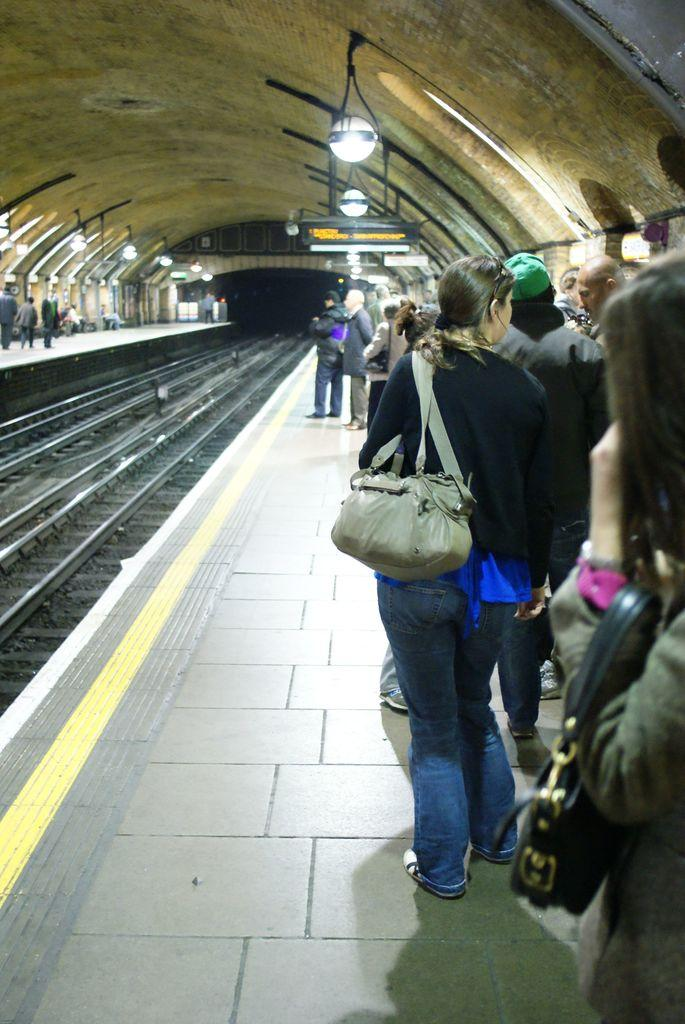What are the persons in the image doing? The persons in the image are standing on a platform. Where is the platform located? The platform is located near a railway track. What can be seen in the image besides the platform and persons? There are lights visible in the image. What type of structure is present in the image? There is a roof in the image. How many chairs are visible in the image? There are no chairs present in the image. What is the weight of the persons standing on the platform? The weight of the persons cannot be determined from the image alone. 